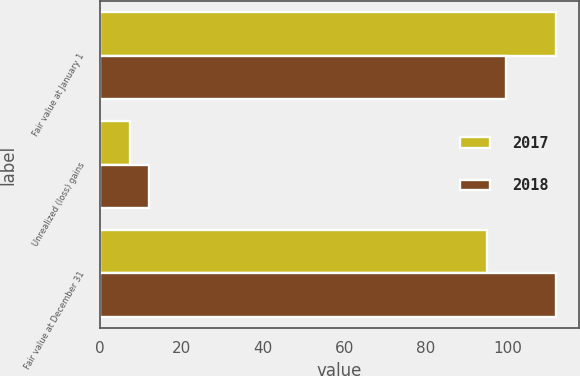Convert chart. <chart><loc_0><loc_0><loc_500><loc_500><stacked_bar_chart><ecel><fcel>Fair value at January 1<fcel>Unrealized (loss) gains<fcel>Fair value at December 31<nl><fcel>2017<fcel>111.9<fcel>7.4<fcel>94.9<nl><fcel>2018<fcel>99.7<fcel>12.2<fcel>111.9<nl></chart> 